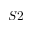Convert formula to latex. <formula><loc_0><loc_0><loc_500><loc_500>S 2</formula> 